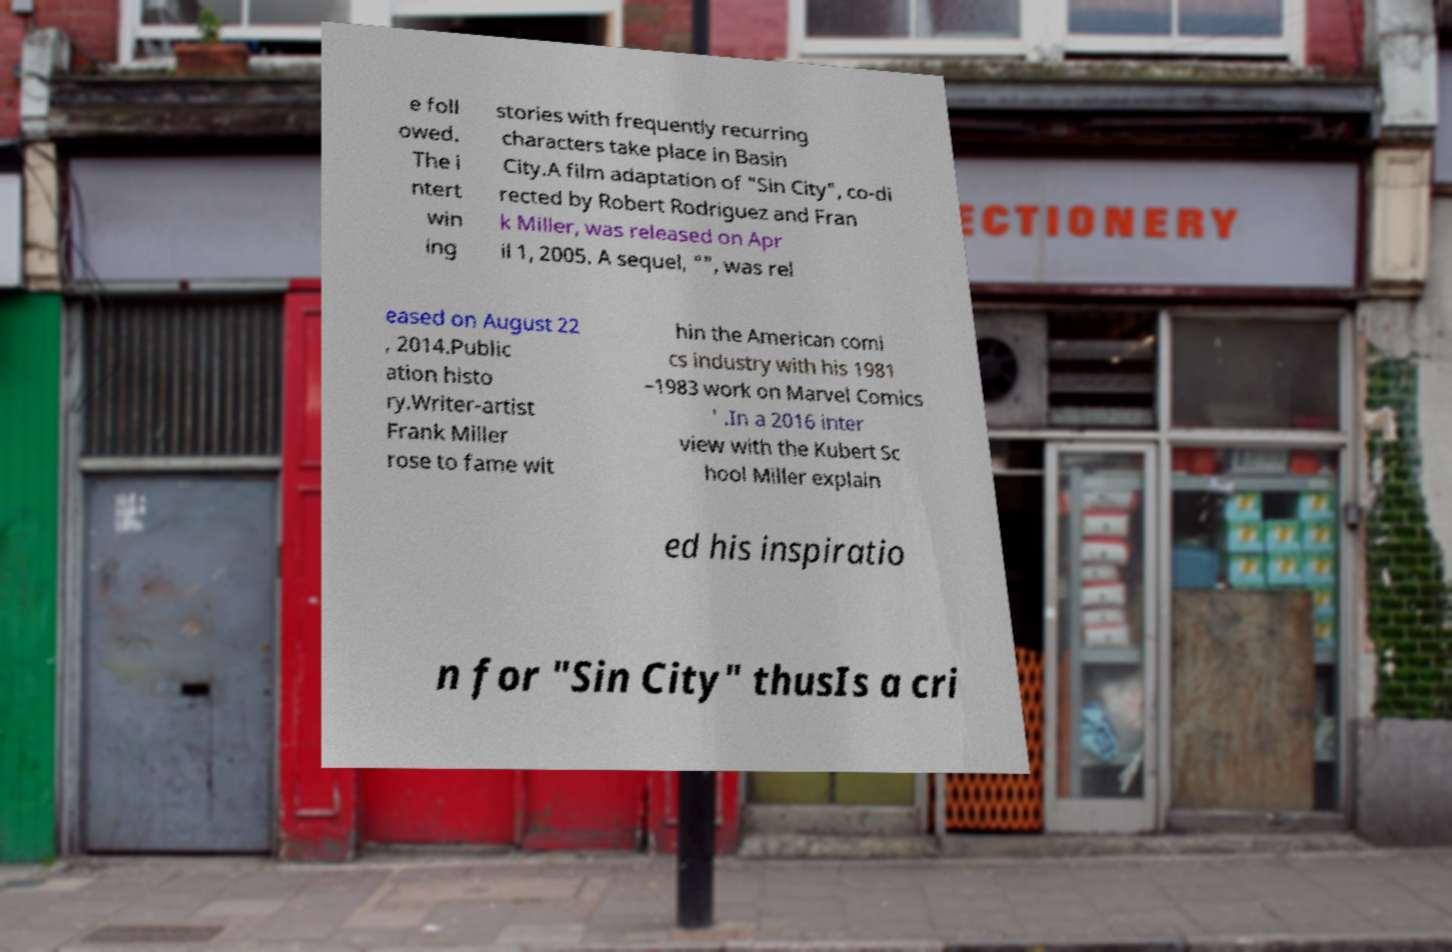Could you extract and type out the text from this image? e foll owed. The i ntert win ing stories with frequently recurring characters take place in Basin City.A film adaptation of "Sin City", co-di rected by Robert Rodriguez and Fran k Miller, was released on Apr il 1, 2005. A sequel, "", was rel eased on August 22 , 2014.Public ation histo ry.Writer-artist Frank Miller rose to fame wit hin the American comi cs industry with his 1981 –1983 work on Marvel Comics ' .In a 2016 inter view with the Kubert Sc hool Miller explain ed his inspiratio n for "Sin City" thusIs a cri 